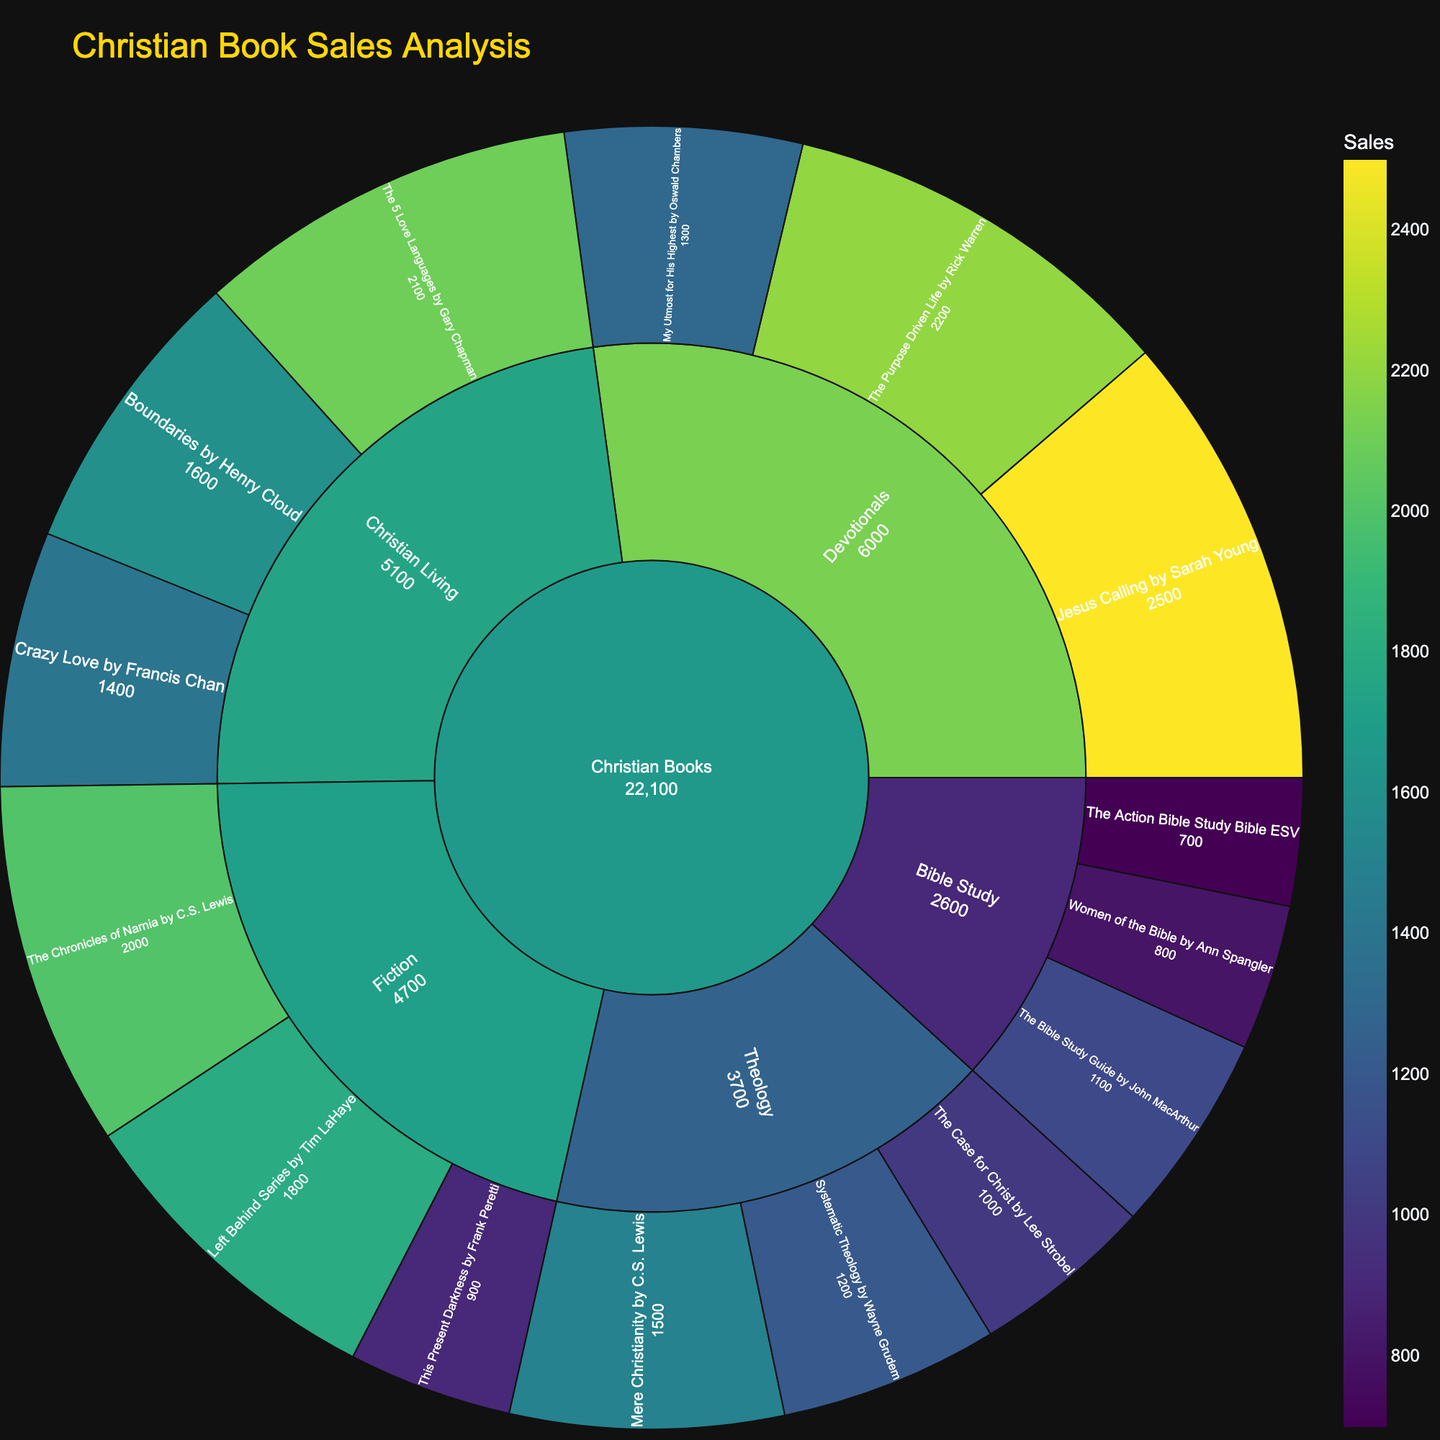What's the title of the Sunburst Plot? The title of the figure is displayed at the top, and it helps to understand what the chart is about. Look at the top of the plot for the text.
Answer: Christian Book Sales Analysis Which segment has the highest value in sales? The highest value can be identified by examining the segments of the Sunburst Plot and finding the one with the largest value. The largest segment is visually distinct with the greatest number.
Answer: Jesus Calling by Sarah Young What is the total sales value for the "Devotionals" subcategory? Sum the values of all items under the "Devotionals" subcategory. "Jesus Calling" (2500) + "My Utmost for His Highest" (1300) + "The Purpose Driven Life" (2200) = 2500 + 1300 + 2200
Answer: 6000 Which author has contributed the most to the "Fiction" subcategory? Compare the sales values of items under the "Fiction" subcategory by different authors. "The Chronicles of Narnia" (2000) by C.S. Lewis, "Left Behind Series" (1800) by Tim LaHaye, and "This Present Darkness" (900) by Frank Peretti.
Answer: C.S. Lewis What is the sales difference between "Theology" and "Bible Study" subcategories? Sum the values of items under both subcategories and then find the difference. Theology: "Systematic Theology" (1200) + "Mere Christianity" (1500) + "The Case for Christ" (1000) = 3700. Bible Study: "The Bible Study Guide" (1100) + "Women of the Bible" (800) + "The Action Bible Study Bible ESV" (700) = 2600. Difference: 3700 - 2600
Answer: 1100 Which subcategory has the smallest total sales value? Examine the total sales values for each subcategory by summing their individual item values. Compare totals for each subcategory and identify the smallest.
Answer: Bible Study How many books has C.S. Lewis written in the provided data? Count the number of items written by C.S. Lewis from the plot. Look for both "Mere Christianity" and "The Chronicles of Narnia".
Answer: 2 In the "Christian Living" subcategory, which item has the second highest sales value? Compare the sales values of items under the "Christian Living" subcategory and identify the second highest. "Boundaries" (1600), "The 5 Love Languages" (2100), and "Crazy Love" (1400).
Answer: Boundaries by Henry Cloud Which item in the "Theology" subcategory has the lowest sales value? Compare the sales values of items under the "Theology" subcategory and identify the smallest value. "Systematic Theology" (1200), "Mere Christianity" (1500), "The Case for Christ" (1000).
Answer: The Case for Christ by Lee Strobel 